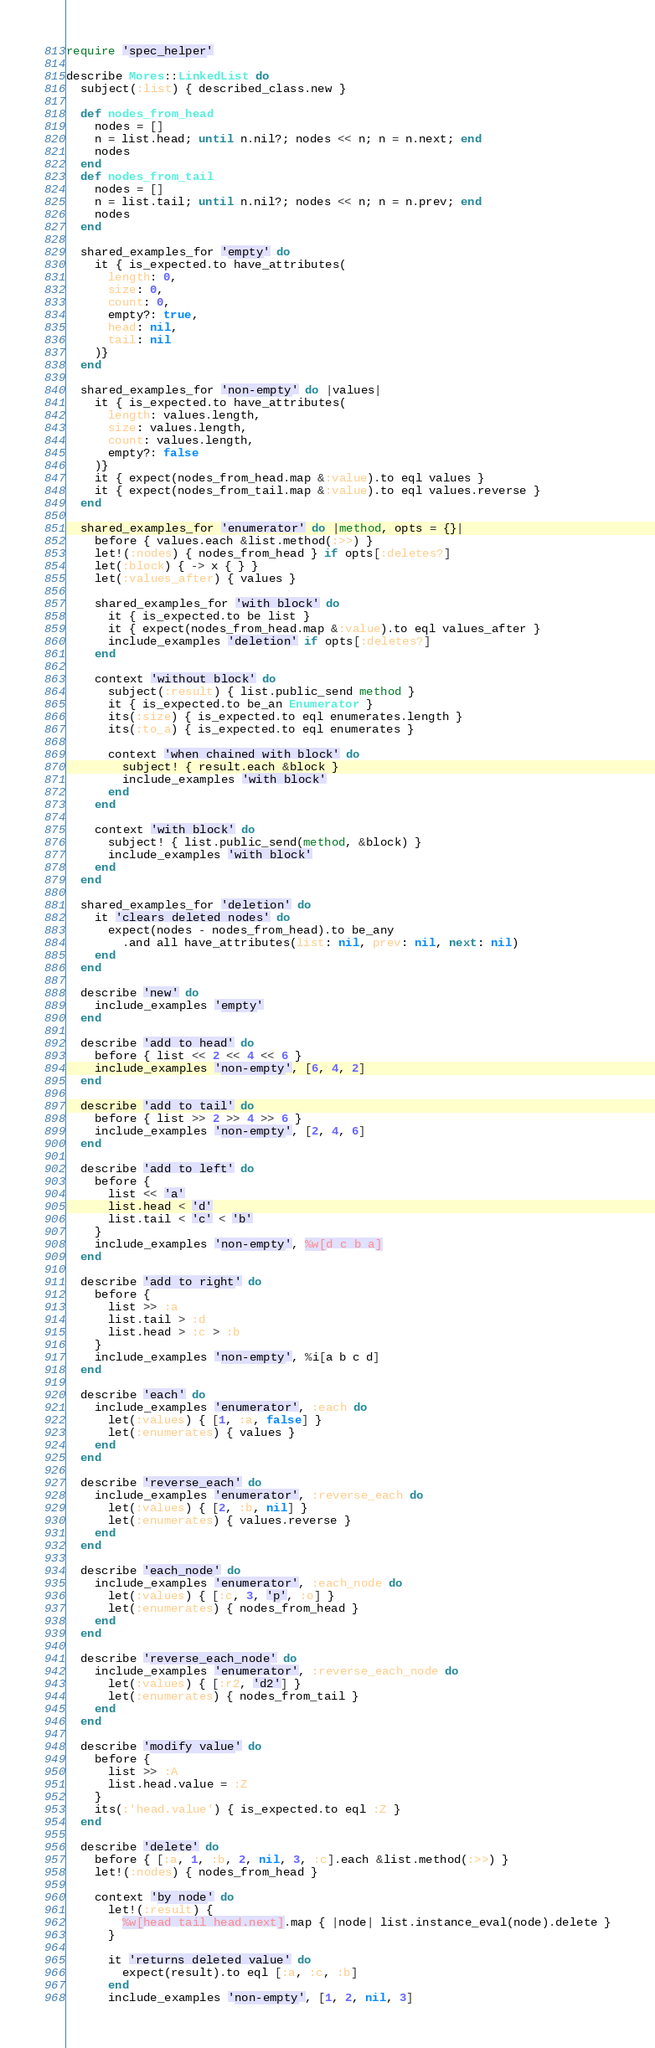<code> <loc_0><loc_0><loc_500><loc_500><_Ruby_>require 'spec_helper'

describe Mores::LinkedList do
  subject(:list) { described_class.new }

  def nodes_from_head
    nodes = []
    n = list.head; until n.nil?; nodes << n; n = n.next; end
    nodes
  end
  def nodes_from_tail
    nodes = []
    n = list.tail; until n.nil?; nodes << n; n = n.prev; end
    nodes
  end

  shared_examples_for 'empty' do
    it { is_expected.to have_attributes(
      length: 0,
      size: 0,
      count: 0,
      empty?: true,
      head: nil,
      tail: nil
    )}
  end

  shared_examples_for 'non-empty' do |values|
    it { is_expected.to have_attributes(
      length: values.length,
      size: values.length,
      count: values.length,
      empty?: false
    )}
    it { expect(nodes_from_head.map &:value).to eql values }
    it { expect(nodes_from_tail.map &:value).to eql values.reverse }
  end

  shared_examples_for 'enumerator' do |method, opts = {}|
    before { values.each &list.method(:>>) }
    let!(:nodes) { nodes_from_head } if opts[:deletes?]
    let(:block) { -> x { } }
    let(:values_after) { values }

    shared_examples_for 'with block' do
      it { is_expected.to be list }
      it { expect(nodes_from_head.map &:value).to eql values_after }
      include_examples 'deletion' if opts[:deletes?]
    end

    context 'without block' do
      subject(:result) { list.public_send method }
      it { is_expected.to be_an Enumerator }
      its(:size) { is_expected.to eql enumerates.length }
      its(:to_a) { is_expected.to eql enumerates }

      context 'when chained with block' do
        subject! { result.each &block }
        include_examples 'with block'
      end
    end

    context 'with block' do
      subject! { list.public_send(method, &block) }
      include_examples 'with block'
    end
  end

  shared_examples_for 'deletion' do
    it 'clears deleted nodes' do
      expect(nodes - nodes_from_head).to be_any
        .and all have_attributes(list: nil, prev: nil, next: nil)
    end
  end

  describe 'new' do
    include_examples 'empty'
  end

  describe 'add to head' do
    before { list << 2 << 4 << 6 }
    include_examples 'non-empty', [6, 4, 2]
  end

  describe 'add to tail' do
    before { list >> 2 >> 4 >> 6 }
    include_examples 'non-empty', [2, 4, 6]
  end

  describe 'add to left' do
    before {
      list << 'a'
      list.head < 'd'
      list.tail < 'c' < 'b'
    }
    include_examples 'non-empty', %w[d c b a]
  end

  describe 'add to right' do
    before {
      list >> :a
      list.tail > :d
      list.head > :c > :b
    }
    include_examples 'non-empty', %i[a b c d]
  end

  describe 'each' do
    include_examples 'enumerator', :each do
      let(:values) { [1, :a, false] }
      let(:enumerates) { values }
    end
  end

  describe 'reverse_each' do
    include_examples 'enumerator', :reverse_each do
      let(:values) { [2, :b, nil] }
      let(:enumerates) { values.reverse }
    end
  end

  describe 'each_node' do
    include_examples 'enumerator', :each_node do
      let(:values) { [:c, 3, 'p', :o] }
      let(:enumerates) { nodes_from_head }
    end
  end

  describe 'reverse_each_node' do
    include_examples 'enumerator', :reverse_each_node do
      let(:values) { [:r2, 'd2'] }
      let(:enumerates) { nodes_from_tail }
    end
  end

  describe 'modify value' do
    before {
      list >> :A
      list.head.value = :Z
    }
    its(:'head.value') { is_expected.to eql :Z }
  end

  describe 'delete' do
    before { [:a, 1, :b, 2, nil, 3, :c].each &list.method(:>>) }
    let!(:nodes) { nodes_from_head }

    context 'by node' do
      let!(:result) {
        %w[head tail head.next].map { |node| list.instance_eval(node).delete }
      }

      it 'returns deleted value' do
        expect(result).to eql [:a, :c, :b]
      end
      include_examples 'non-empty', [1, 2, nil, 3]</code> 